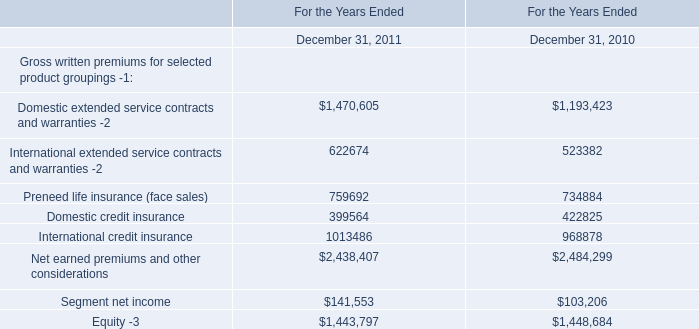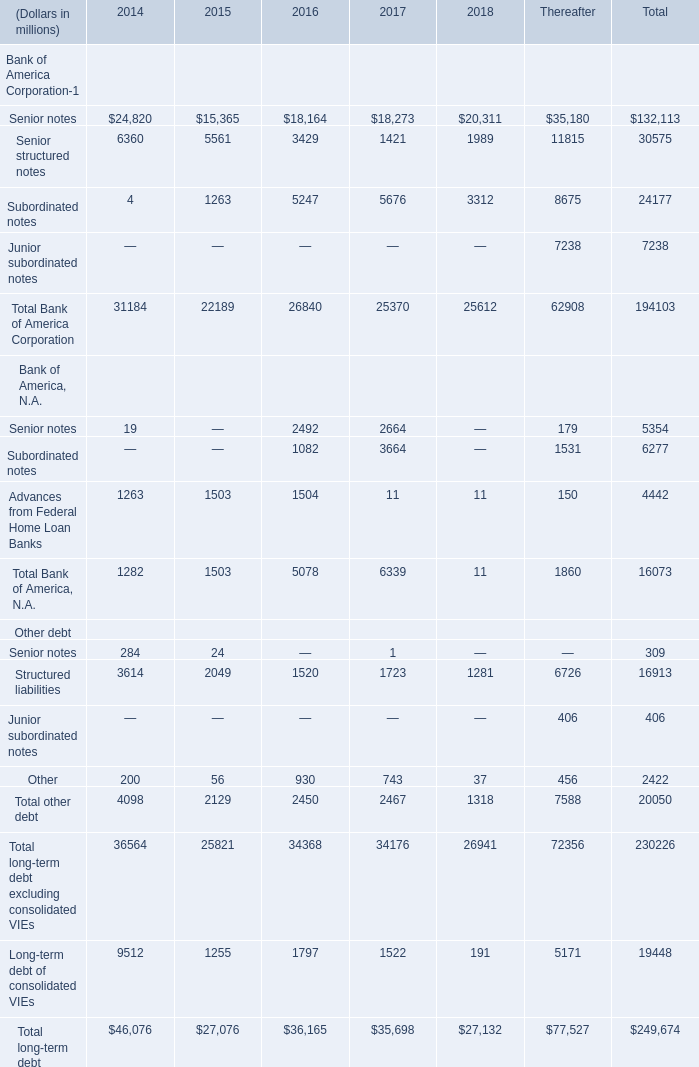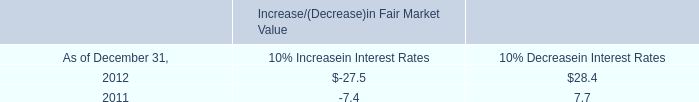How many Bank of America Corporation Senior notes exceed the average of Bank of America Corporation in 2016? (in million) 
Computations: (18164 - (26840 / 4))
Answer: 11454.0. 